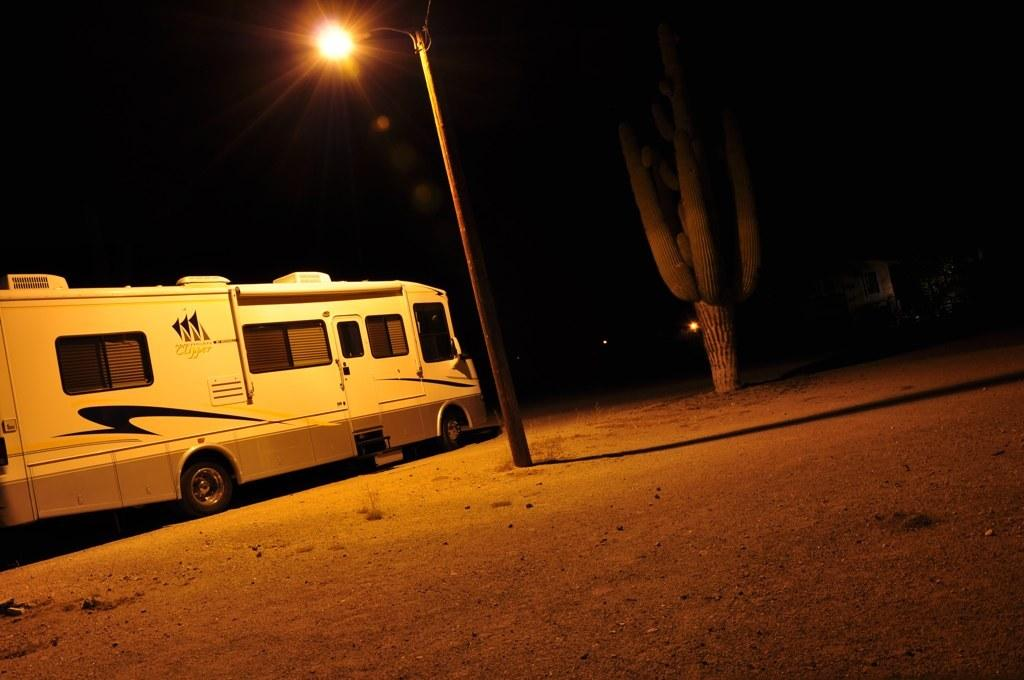What is the main subject of the image? The main subject of the image is a bus. What features can be seen on the bus? The bus has windows. What other objects are present in the image? There is a light pole and a cactus plant in the image. How would you describe the background of the image? The background of the image is dark. Can you tell me how many trucks are parked next to the bus in the image? There is no truck present in the image; only a bus, a light pole, a cactus plant, and a dark background are visible. What type of bird's nest can be seen on the cactus plant in the image? There is no bird's nest visible on the cactus plant in the image. 